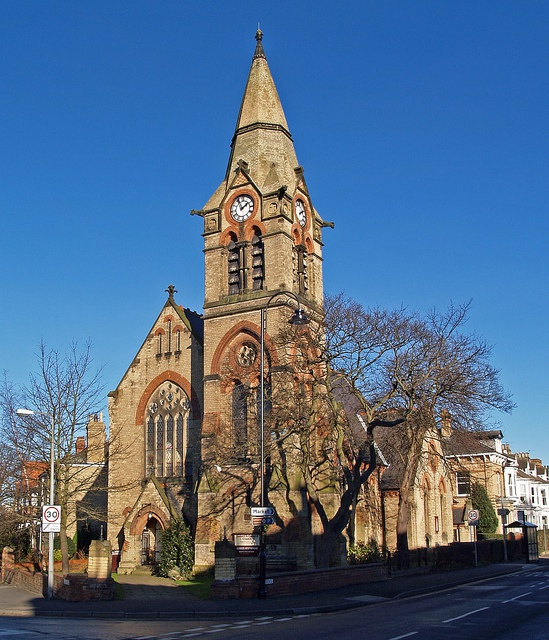Describe the objects in this image and their specific colors. I can see clock in blue, white, darkgray, gray, and black tones and clock in blue, white, gray, black, and darkgray tones in this image. 